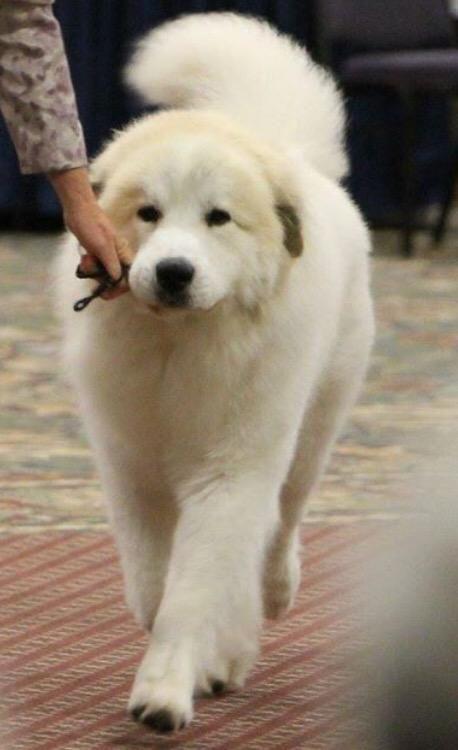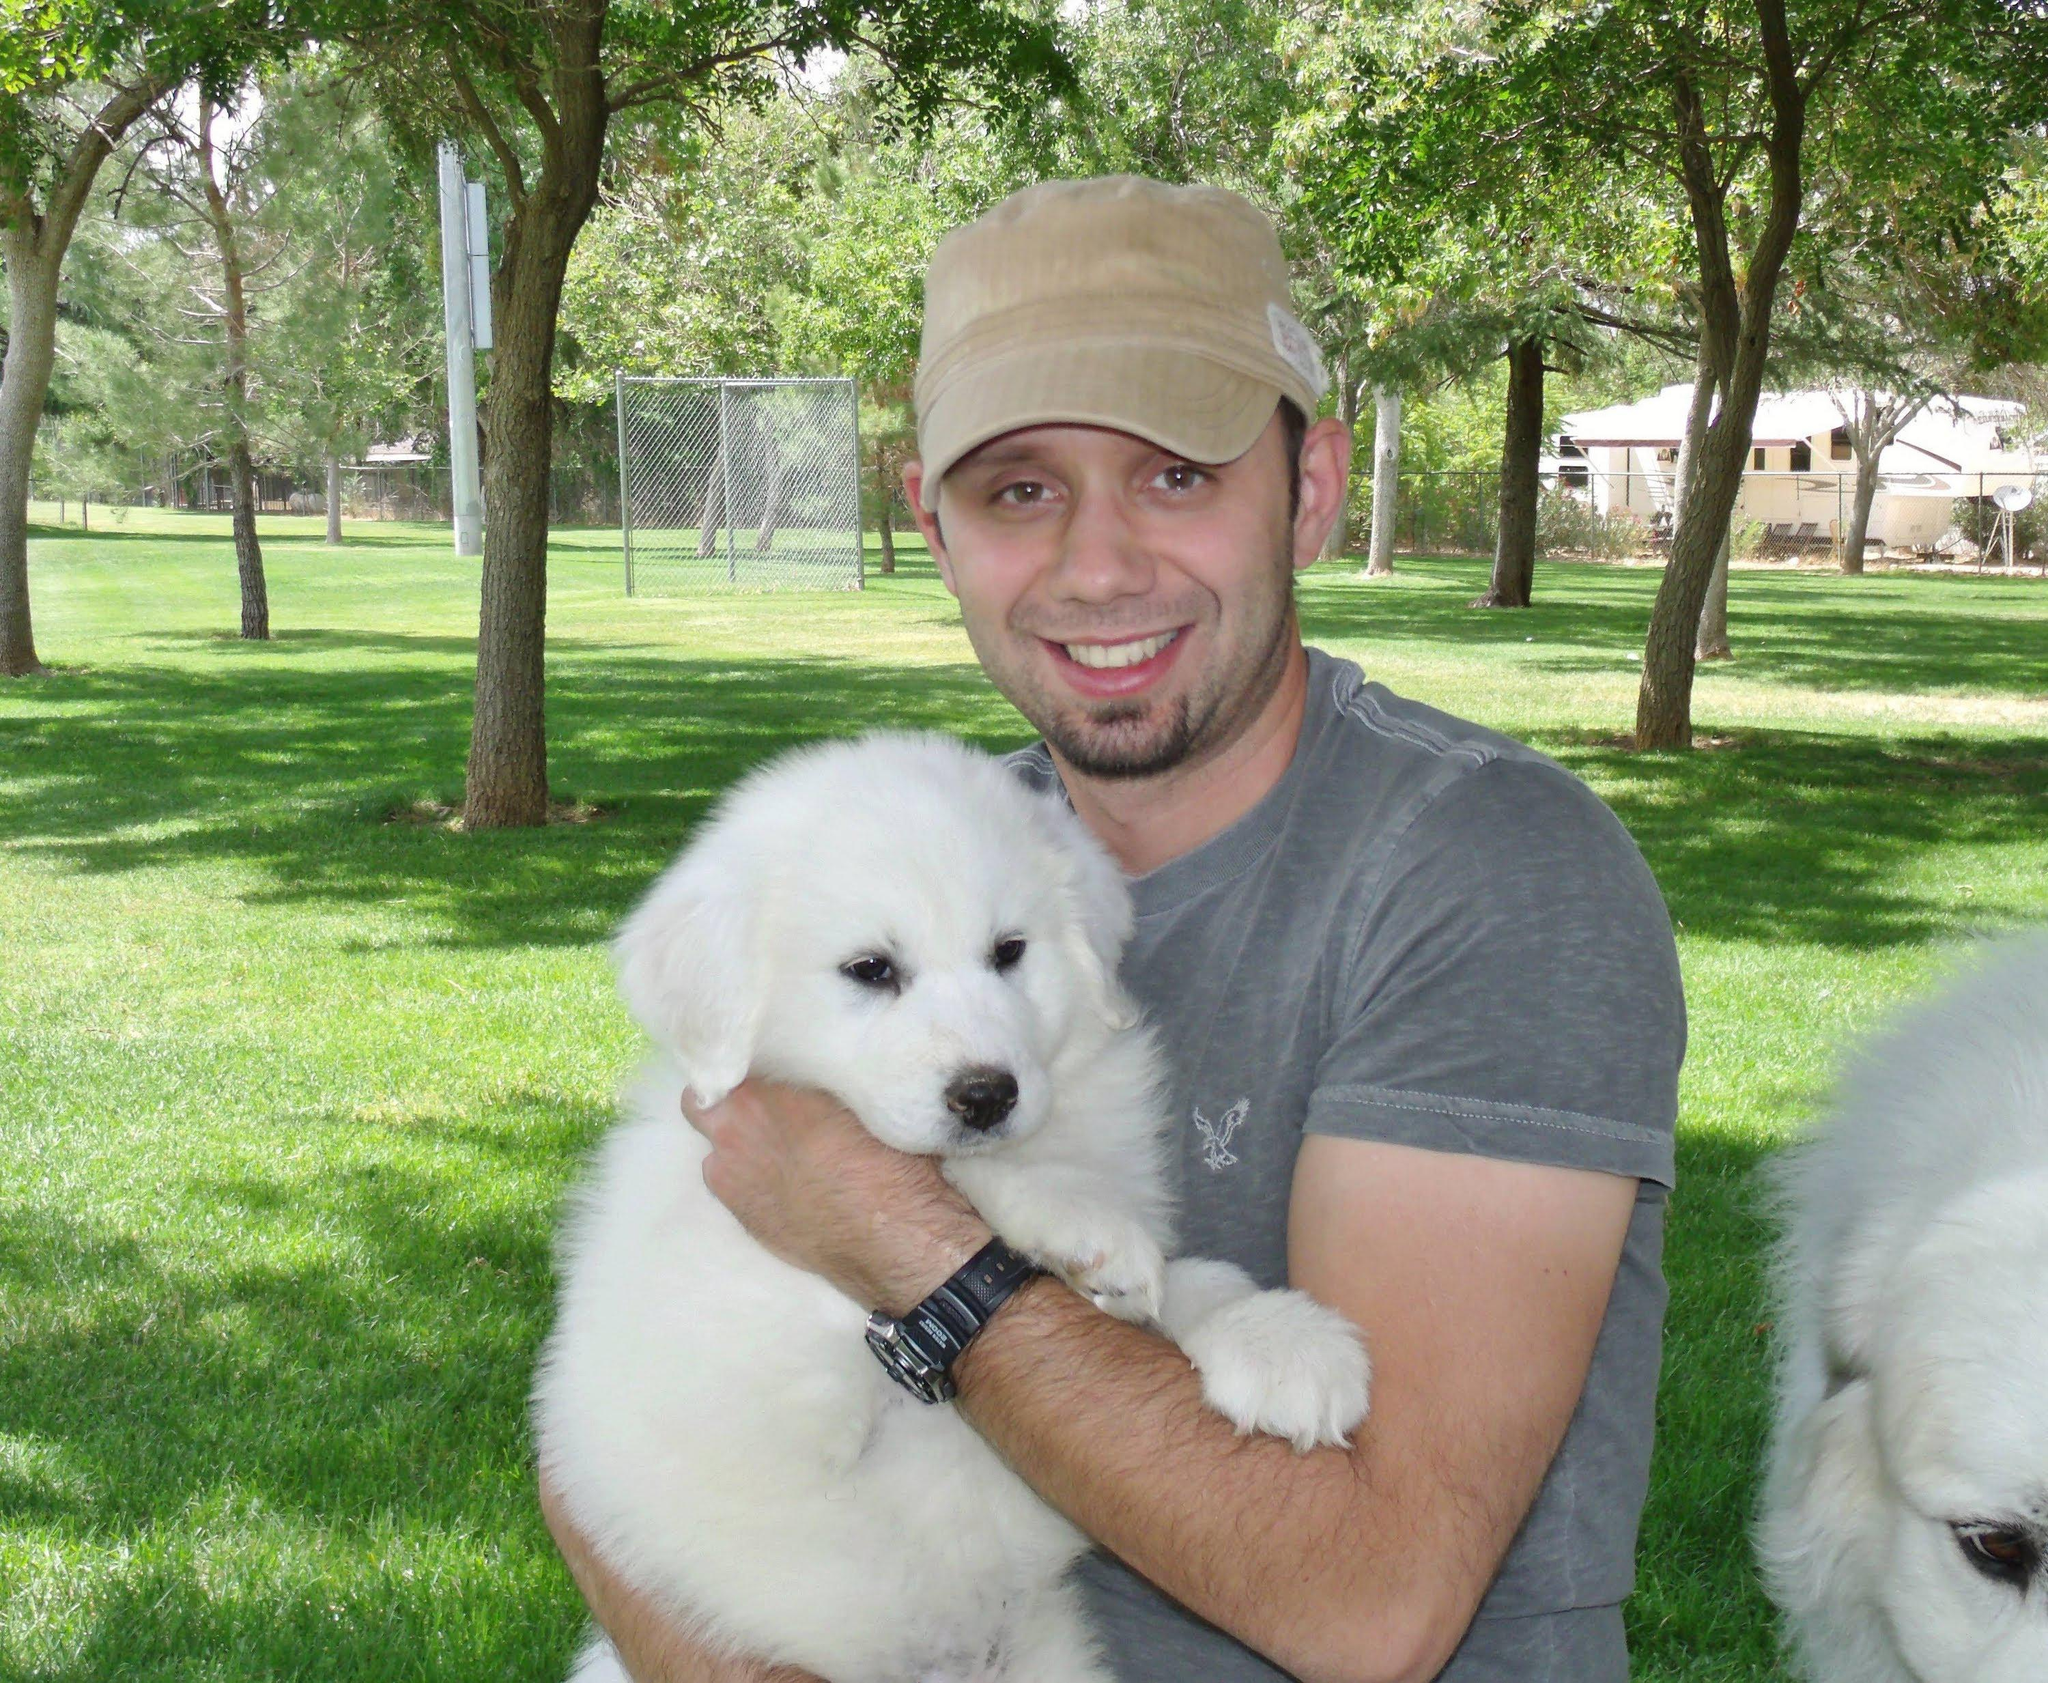The first image is the image on the left, the second image is the image on the right. For the images shown, is this caption "In total, only two fluffy dogs can be seen in these images." true? Answer yes or no. No. The first image is the image on the left, the second image is the image on the right. Analyze the images presented: Is the assertion "There are two dogs" valid? Answer yes or no. No. 